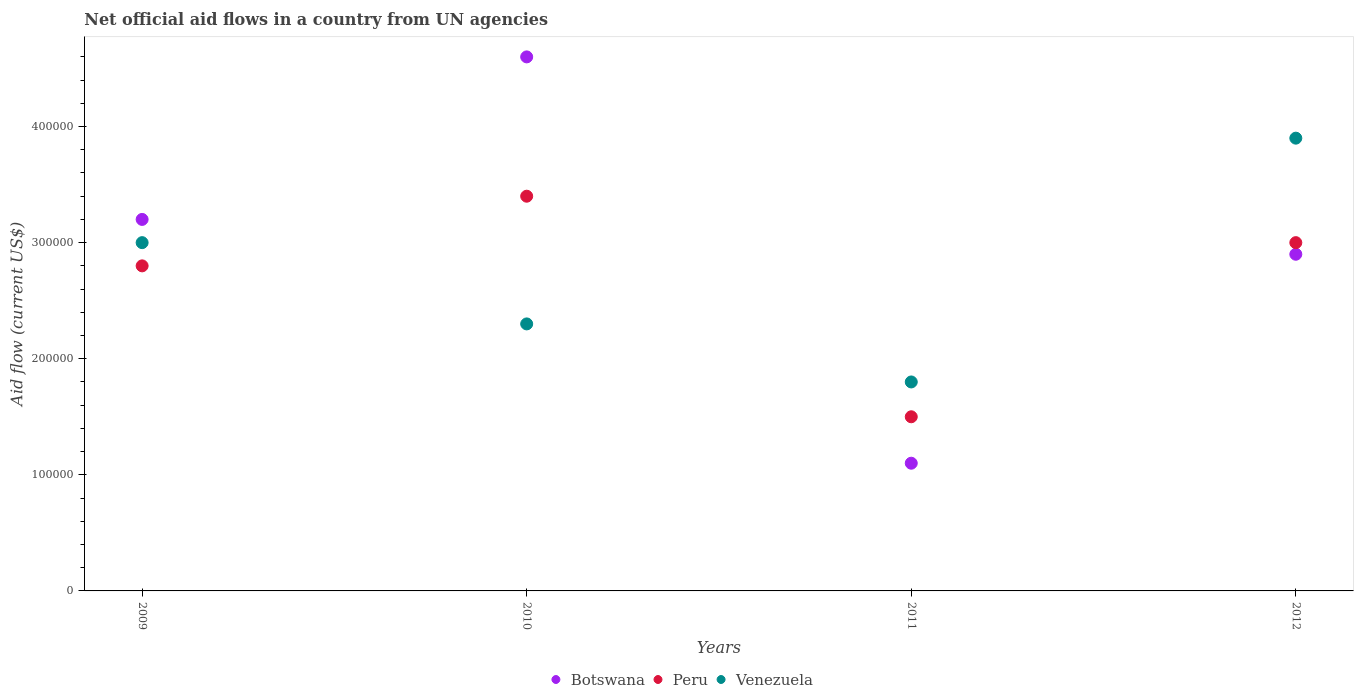Is the number of dotlines equal to the number of legend labels?
Give a very brief answer. Yes. What is the net official aid flow in Peru in 2012?
Make the answer very short. 3.00e+05. Across all years, what is the maximum net official aid flow in Venezuela?
Provide a succinct answer. 3.90e+05. Across all years, what is the minimum net official aid flow in Botswana?
Make the answer very short. 1.10e+05. In which year was the net official aid flow in Venezuela minimum?
Offer a very short reply. 2011. What is the total net official aid flow in Botswana in the graph?
Provide a short and direct response. 1.18e+06. What is the difference between the net official aid flow in Botswana in 2011 and that in 2012?
Provide a short and direct response. -1.80e+05. What is the difference between the net official aid flow in Botswana in 2011 and the net official aid flow in Peru in 2012?
Provide a succinct answer. -1.90e+05. What is the average net official aid flow in Botswana per year?
Give a very brief answer. 2.95e+05. In the year 2009, what is the difference between the net official aid flow in Venezuela and net official aid flow in Botswana?
Offer a very short reply. -2.00e+04. In how many years, is the net official aid flow in Venezuela greater than 80000 US$?
Your answer should be compact. 4. What is the ratio of the net official aid flow in Venezuela in 2011 to that in 2012?
Ensure brevity in your answer.  0.46. Is the net official aid flow in Botswana in 2009 less than that in 2011?
Give a very brief answer. No. What is the difference between the highest and the lowest net official aid flow in Botswana?
Your answer should be very brief. 3.50e+05. In how many years, is the net official aid flow in Venezuela greater than the average net official aid flow in Venezuela taken over all years?
Your response must be concise. 2. Is the sum of the net official aid flow in Botswana in 2010 and 2012 greater than the maximum net official aid flow in Venezuela across all years?
Ensure brevity in your answer.  Yes. Does the net official aid flow in Peru monotonically increase over the years?
Your answer should be very brief. No. Is the net official aid flow in Venezuela strictly greater than the net official aid flow in Botswana over the years?
Your answer should be compact. No. Is the net official aid flow in Peru strictly less than the net official aid flow in Venezuela over the years?
Provide a short and direct response. No. How many years are there in the graph?
Your response must be concise. 4. What is the difference between two consecutive major ticks on the Y-axis?
Offer a terse response. 1.00e+05. Are the values on the major ticks of Y-axis written in scientific E-notation?
Offer a very short reply. No. Does the graph contain any zero values?
Keep it short and to the point. No. How are the legend labels stacked?
Offer a very short reply. Horizontal. What is the title of the graph?
Keep it short and to the point. Net official aid flows in a country from UN agencies. What is the label or title of the X-axis?
Keep it short and to the point. Years. What is the label or title of the Y-axis?
Ensure brevity in your answer.  Aid flow (current US$). What is the Aid flow (current US$) in Peru in 2009?
Your response must be concise. 2.80e+05. What is the Aid flow (current US$) in Venezuela in 2009?
Offer a very short reply. 3.00e+05. What is the Aid flow (current US$) in Botswana in 2010?
Provide a succinct answer. 4.60e+05. What is the Aid flow (current US$) in Peru in 2011?
Your answer should be compact. 1.50e+05. What is the Aid flow (current US$) in Botswana in 2012?
Ensure brevity in your answer.  2.90e+05. What is the Aid flow (current US$) in Peru in 2012?
Offer a terse response. 3.00e+05. What is the Aid flow (current US$) in Venezuela in 2012?
Make the answer very short. 3.90e+05. Across all years, what is the maximum Aid flow (current US$) of Botswana?
Ensure brevity in your answer.  4.60e+05. Across all years, what is the minimum Aid flow (current US$) in Peru?
Your response must be concise. 1.50e+05. What is the total Aid flow (current US$) of Botswana in the graph?
Offer a terse response. 1.18e+06. What is the total Aid flow (current US$) in Peru in the graph?
Your answer should be very brief. 1.07e+06. What is the total Aid flow (current US$) of Venezuela in the graph?
Provide a succinct answer. 1.10e+06. What is the difference between the Aid flow (current US$) in Botswana in 2009 and that in 2010?
Give a very brief answer. -1.40e+05. What is the difference between the Aid flow (current US$) in Peru in 2009 and that in 2011?
Provide a short and direct response. 1.30e+05. What is the difference between the Aid flow (current US$) of Venezuela in 2009 and that in 2012?
Your response must be concise. -9.00e+04. What is the difference between the Aid flow (current US$) in Botswana in 2010 and that in 2011?
Give a very brief answer. 3.50e+05. What is the difference between the Aid flow (current US$) in Venezuela in 2011 and that in 2012?
Your response must be concise. -2.10e+05. What is the difference between the Aid flow (current US$) of Botswana in 2009 and the Aid flow (current US$) of Peru in 2010?
Keep it short and to the point. -2.00e+04. What is the difference between the Aid flow (current US$) in Botswana in 2009 and the Aid flow (current US$) in Venezuela in 2010?
Your response must be concise. 9.00e+04. What is the difference between the Aid flow (current US$) in Peru in 2009 and the Aid flow (current US$) in Venezuela in 2010?
Make the answer very short. 5.00e+04. What is the difference between the Aid flow (current US$) in Botswana in 2009 and the Aid flow (current US$) in Venezuela in 2012?
Offer a terse response. -7.00e+04. What is the difference between the Aid flow (current US$) of Peru in 2009 and the Aid flow (current US$) of Venezuela in 2012?
Ensure brevity in your answer.  -1.10e+05. What is the difference between the Aid flow (current US$) in Botswana in 2010 and the Aid flow (current US$) in Venezuela in 2011?
Your answer should be very brief. 2.80e+05. What is the difference between the Aid flow (current US$) of Botswana in 2010 and the Aid flow (current US$) of Venezuela in 2012?
Provide a succinct answer. 7.00e+04. What is the difference between the Aid flow (current US$) in Peru in 2010 and the Aid flow (current US$) in Venezuela in 2012?
Offer a terse response. -5.00e+04. What is the difference between the Aid flow (current US$) of Botswana in 2011 and the Aid flow (current US$) of Venezuela in 2012?
Give a very brief answer. -2.80e+05. What is the average Aid flow (current US$) in Botswana per year?
Your answer should be compact. 2.95e+05. What is the average Aid flow (current US$) in Peru per year?
Keep it short and to the point. 2.68e+05. What is the average Aid flow (current US$) in Venezuela per year?
Offer a very short reply. 2.75e+05. In the year 2009, what is the difference between the Aid flow (current US$) in Botswana and Aid flow (current US$) in Peru?
Keep it short and to the point. 4.00e+04. In the year 2009, what is the difference between the Aid flow (current US$) of Botswana and Aid flow (current US$) of Venezuela?
Provide a short and direct response. 2.00e+04. In the year 2010, what is the difference between the Aid flow (current US$) of Botswana and Aid flow (current US$) of Peru?
Keep it short and to the point. 1.20e+05. In the year 2010, what is the difference between the Aid flow (current US$) of Botswana and Aid flow (current US$) of Venezuela?
Provide a short and direct response. 2.30e+05. In the year 2011, what is the difference between the Aid flow (current US$) of Peru and Aid flow (current US$) of Venezuela?
Offer a terse response. -3.00e+04. In the year 2012, what is the difference between the Aid flow (current US$) of Botswana and Aid flow (current US$) of Peru?
Provide a succinct answer. -10000. In the year 2012, what is the difference between the Aid flow (current US$) in Botswana and Aid flow (current US$) in Venezuela?
Keep it short and to the point. -1.00e+05. In the year 2012, what is the difference between the Aid flow (current US$) in Peru and Aid flow (current US$) in Venezuela?
Offer a terse response. -9.00e+04. What is the ratio of the Aid flow (current US$) of Botswana in 2009 to that in 2010?
Provide a short and direct response. 0.7. What is the ratio of the Aid flow (current US$) in Peru in 2009 to that in 2010?
Provide a short and direct response. 0.82. What is the ratio of the Aid flow (current US$) of Venezuela in 2009 to that in 2010?
Make the answer very short. 1.3. What is the ratio of the Aid flow (current US$) of Botswana in 2009 to that in 2011?
Your response must be concise. 2.91. What is the ratio of the Aid flow (current US$) of Peru in 2009 to that in 2011?
Provide a short and direct response. 1.87. What is the ratio of the Aid flow (current US$) in Venezuela in 2009 to that in 2011?
Ensure brevity in your answer.  1.67. What is the ratio of the Aid flow (current US$) of Botswana in 2009 to that in 2012?
Your answer should be compact. 1.1. What is the ratio of the Aid flow (current US$) of Peru in 2009 to that in 2012?
Offer a very short reply. 0.93. What is the ratio of the Aid flow (current US$) in Venezuela in 2009 to that in 2012?
Keep it short and to the point. 0.77. What is the ratio of the Aid flow (current US$) of Botswana in 2010 to that in 2011?
Give a very brief answer. 4.18. What is the ratio of the Aid flow (current US$) in Peru in 2010 to that in 2011?
Your answer should be compact. 2.27. What is the ratio of the Aid flow (current US$) of Venezuela in 2010 to that in 2011?
Your answer should be very brief. 1.28. What is the ratio of the Aid flow (current US$) of Botswana in 2010 to that in 2012?
Offer a very short reply. 1.59. What is the ratio of the Aid flow (current US$) of Peru in 2010 to that in 2012?
Provide a short and direct response. 1.13. What is the ratio of the Aid flow (current US$) of Venezuela in 2010 to that in 2012?
Keep it short and to the point. 0.59. What is the ratio of the Aid flow (current US$) of Botswana in 2011 to that in 2012?
Make the answer very short. 0.38. What is the ratio of the Aid flow (current US$) in Venezuela in 2011 to that in 2012?
Keep it short and to the point. 0.46. What is the difference between the highest and the second highest Aid flow (current US$) of Botswana?
Make the answer very short. 1.40e+05. What is the difference between the highest and the second highest Aid flow (current US$) of Venezuela?
Your response must be concise. 9.00e+04. What is the difference between the highest and the lowest Aid flow (current US$) in Botswana?
Your response must be concise. 3.50e+05. What is the difference between the highest and the lowest Aid flow (current US$) in Peru?
Your response must be concise. 1.90e+05. What is the difference between the highest and the lowest Aid flow (current US$) in Venezuela?
Your answer should be compact. 2.10e+05. 